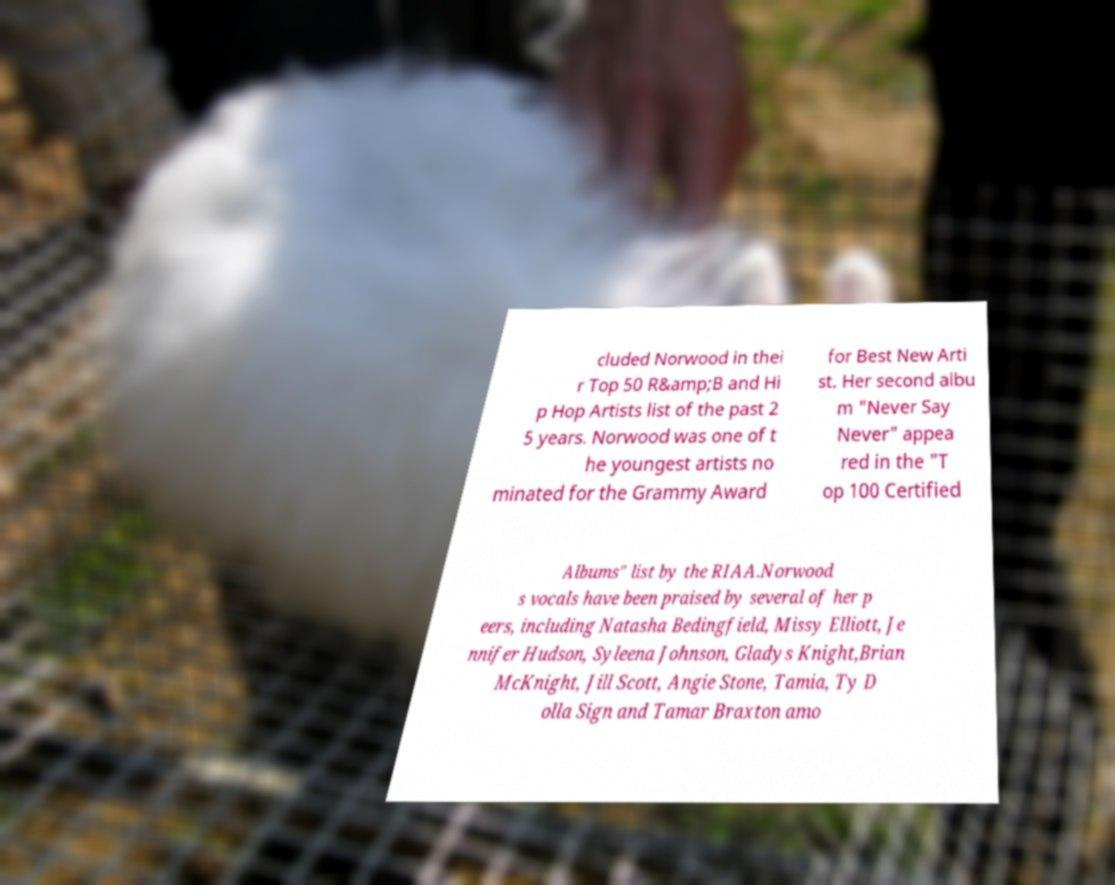There's text embedded in this image that I need extracted. Can you transcribe it verbatim? cluded Norwood in thei r Top 50 R&amp;B and Hi p Hop Artists list of the past 2 5 years. Norwood was one of t he youngest artists no minated for the Grammy Award for Best New Arti st. Her second albu m "Never Say Never" appea red in the "T op 100 Certified Albums" list by the RIAA.Norwood s vocals have been praised by several of her p eers, including Natasha Bedingfield, Missy Elliott, Je nnifer Hudson, Syleena Johnson, Gladys Knight,Brian McKnight, Jill Scott, Angie Stone, Tamia, Ty D olla Sign and Tamar Braxton amo 